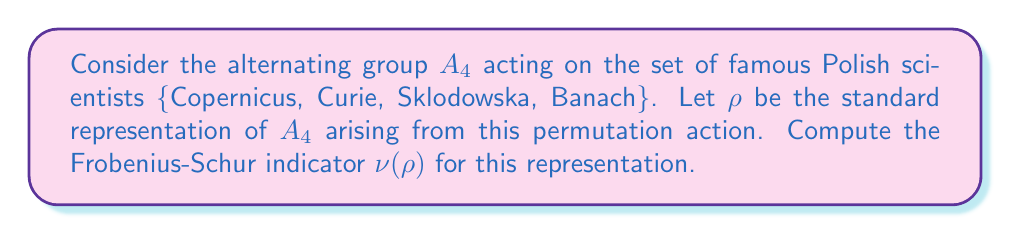Could you help me with this problem? Let's approach this step-by-step:

1) The Frobenius-Schur indicator $\nu(\rho)$ for a representation $\rho$ of a finite group $G$ is given by:

   $$\nu(\rho) = \frac{1}{|G|} \sum_{g \in G} \chi_\rho(g^2)$$

   where $\chi_\rho$ is the character of the representation $\rho$.

2) For $A_4$, we have $|G| = 12$.

3) The standard representation $\rho$ of $A_4$ on 4 elements has character values:
   - $\chi_\rho(e) = 4$ (identity)
   - $\chi_\rho((123)) = 1$ (3-cycles)
   - $\chi_\rho((12)(34)) = 0$ (product of 2 transpositions)

4) We need to sum $\chi_\rho(g^2)$ for all $g \in A_4$:
   - For the identity: $e^2 = e$, contributes 4
   - For 3-cycles: $(123)^2 = (132)$, contributes 1 each, there are 8 of these
   - For products of 2 transpositions: $((12)(34))^2 = e$, contributes 4 each, there are 3 of these

5) Therefore, the sum is:

   $$\sum_{g \in G} \chi_\rho(g^2) = 4 + 8 \cdot 1 + 3 \cdot 4 = 24$$

6) Applying the formula:

   $$\nu(\rho) = \frac{1}{12} \cdot 24 = 2$$
Answer: $\nu(\rho) = 2$ 